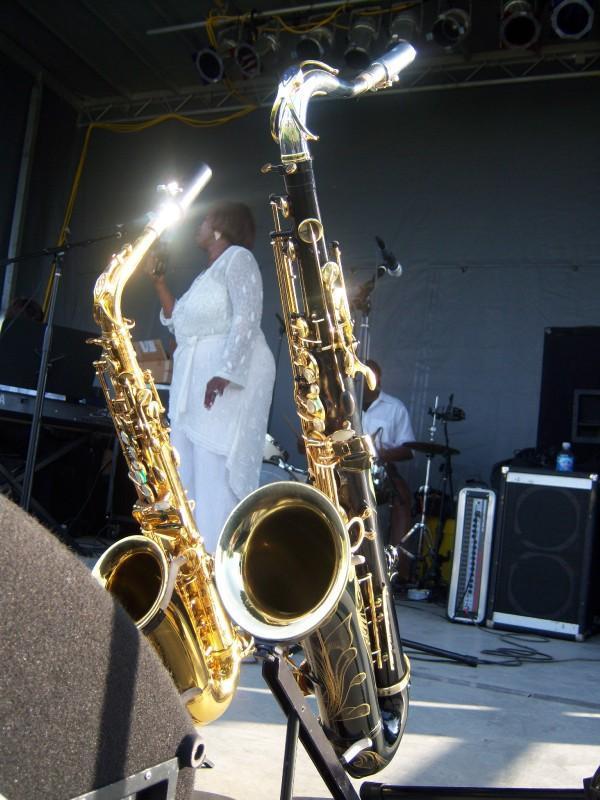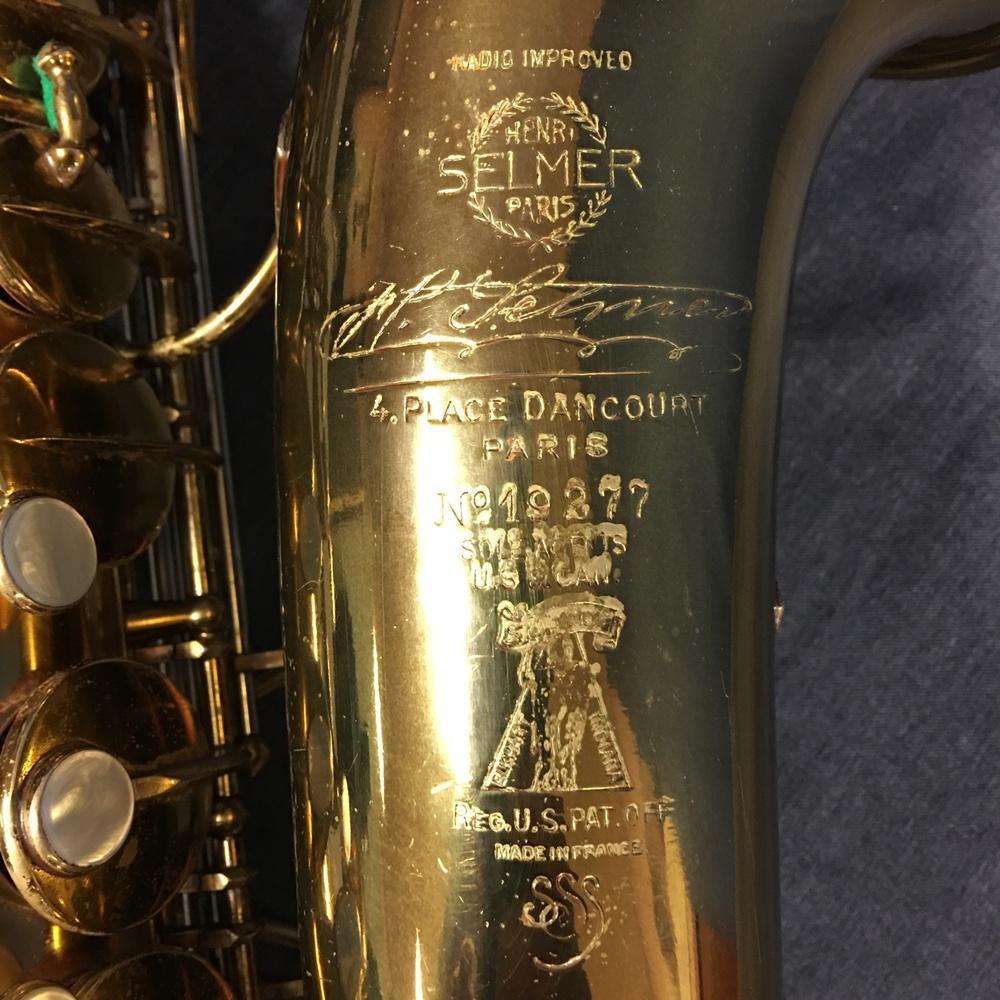The first image is the image on the left, the second image is the image on the right. Examine the images to the left and right. Is the description "A saxophone in one image is positioned inside a dark blue lined case, while a second image shows a section of the gold keys of another saxophone." accurate? Answer yes or no. No. The first image is the image on the left, the second image is the image on the right. Given the left and right images, does the statement "An image shows a saxophone with a mottled finish, displayed in an open plush-lined case." hold true? Answer yes or no. No. 